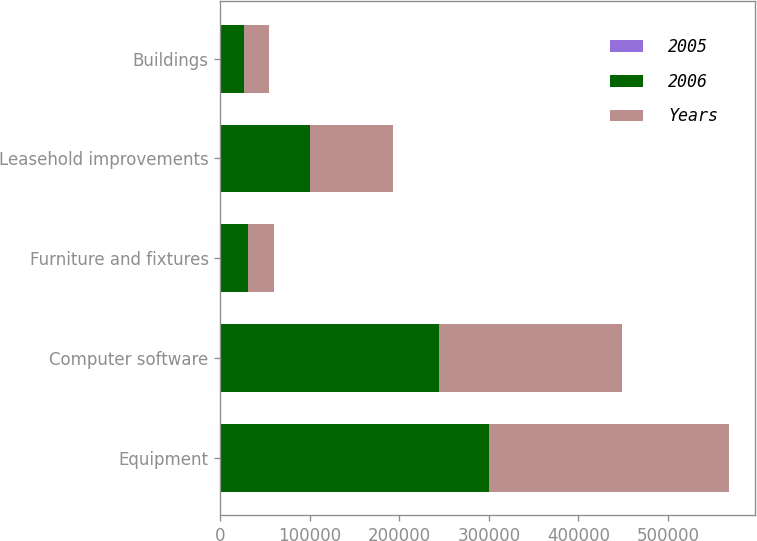Convert chart to OTSL. <chart><loc_0><loc_0><loc_500><loc_500><stacked_bar_chart><ecel><fcel>Equipment<fcel>Computer software<fcel>Furniture and fixtures<fcel>Leasehold improvements<fcel>Buildings<nl><fcel>2005<fcel>35<fcel>35<fcel>15<fcel>112<fcel>30<nl><fcel>2006<fcel>300086<fcel>243727<fcel>30568<fcel>99977<fcel>25988<nl><fcel>Years<fcel>268472<fcel>204649<fcel>29631<fcel>92767<fcel>28097<nl></chart> 